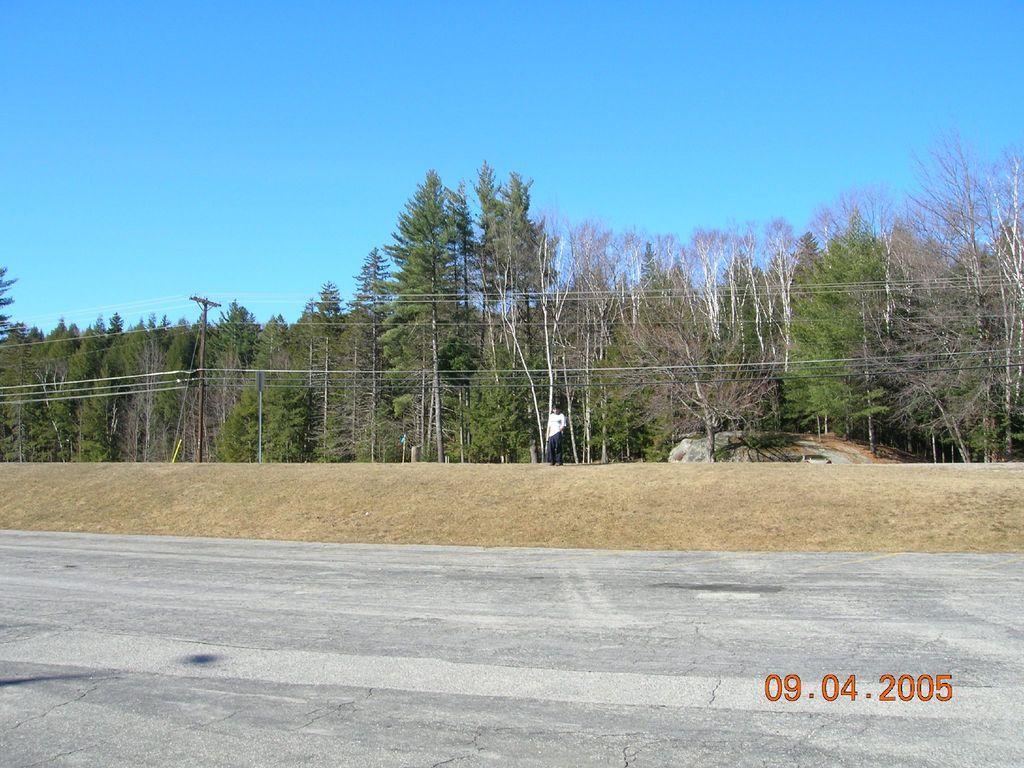In one or two sentences, can you explain what this image depicts? This image is clicked outside. There are trees in the middle. There is pole on the left side. There is sky at the top. 